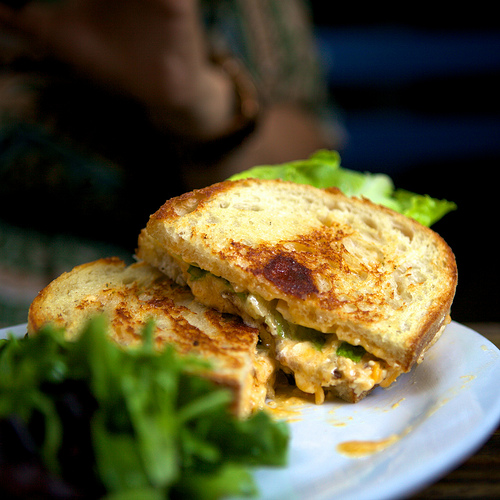<image>
Is the lettuce under the bread? Yes. The lettuce is positioned underneath the bread, with the bread above it in the vertical space. 